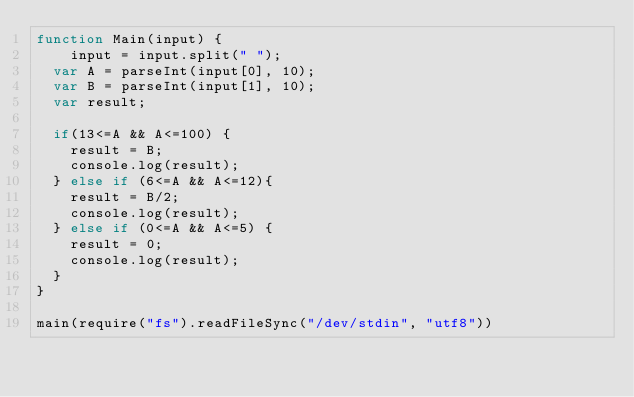<code> <loc_0><loc_0><loc_500><loc_500><_JavaScript_>function Main(input) {
	input = input.split(" ");
  var A = parseInt(input[0], 10);
  var B = parseInt(input[1], 10);
  var result;

  if(13<=A && A<=100) {
    result = B;
    console.log(result);
  } else if (6<=A && A<=12){
    result = B/2;           
    console.log(result);
  } else if (0<=A && A<=5) {
    result = 0;
    console.log(result);
  }
}

main(require("fs").readFileSync("/dev/stdin", "utf8"))</code> 